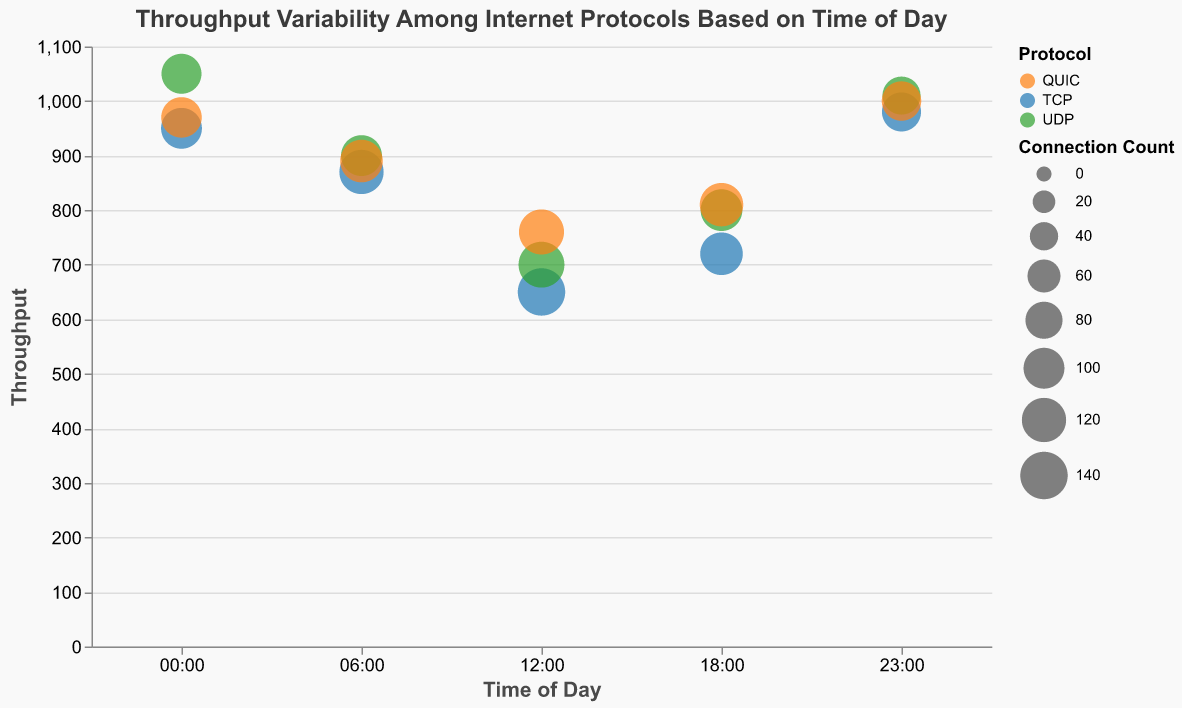What is the title of the chart? The title of the chart is located at the top and it reads "Throughput Variability Among Internet Protocols Based on Time of Day".
Answer: "Throughput Variability Among Internet Protocols Based on Time of Day" Which protocol has the highest throughput at 12:00? At 12:00, the throughputs for the protocols are: TCP: 650, UDP: 700, and QUIC: 760. Comparing these values, QUIC has the highest throughput.
Answer: QUIC What is the variability for UDP at 18:00? According to the tooltip information for the bubble representing UDP at 18:00, the variability is marked as 15.
Answer: 15 How does the throughput at 06:00 for TCP compare to UDP? At 06:00, the throughput for TCP is 870, and for UDP, it is 900. Therefore, UDP has a higher throughput than TCP at this time.
Answer: UDP has higher throughput Which time slot has the most significant difference in throughput among protocols? List the values. To find the most significant difference in throughput among protocols, we need to identify the time slot with the widest range between the minimum and maximum throughputs for TCP, UDP, and QUIC. At 12:00, the values are: TCP: 650, UDP: 700, and QUIC: 760. The difference is 760 - 650 = 110. At other times, the differences are smaller.
Answer: 12:00 (Values: TCP: 650, UDP: 700, QUIC: 760) Which protocol shows the least variability at any given time of day? Examining the variabilities, the lowest value is 5, occurring for TCP at 00:00, TCP at 23:00, and UDP at 23:00. Therefore, TCP and UDP show the least variability at these times.
Answer: TCP (00:00 and 23:00), UDP (23:00) What is the total connection count for QUIC across all time intervals? Summing the connection counts for QUIC across all times: 98 + 110 + 125 + 115 + 92 = 540.
Answer: 540 How does the smallest bubble (in terms of connection count) compare in terms of throughput and variability? The smallest bubble corresponds to UDP at 23:00 with a connection count of 85. This bubble has a throughput of 1010 and a variability of 5.
Answer: Throughput: 1010, Variability: 5 Which protocol generally achieves the highest throughput? By examining the throughputs at different times of day for each protocol, UDP consistently achieves high throughputs at every time slot (e.g., 1050 at 00:00, 1010 at 23:00).
Answer: UDP 